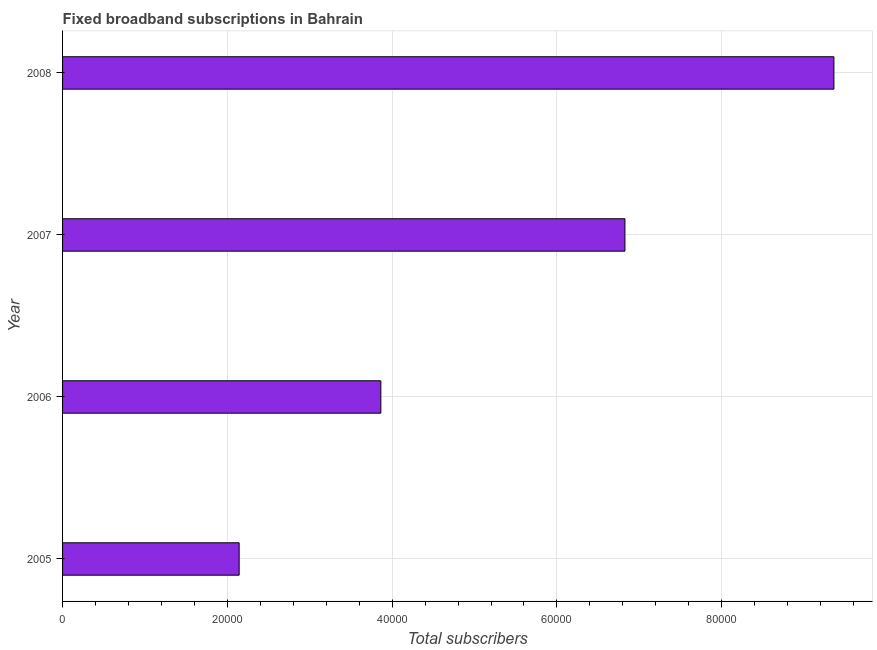Does the graph contain any zero values?
Offer a terse response. No. Does the graph contain grids?
Offer a very short reply. Yes. What is the title of the graph?
Your response must be concise. Fixed broadband subscriptions in Bahrain. What is the label or title of the X-axis?
Your response must be concise. Total subscribers. What is the total number of fixed broadband subscriptions in 2005?
Your response must be concise. 2.14e+04. Across all years, what is the maximum total number of fixed broadband subscriptions?
Make the answer very short. 9.36e+04. Across all years, what is the minimum total number of fixed broadband subscriptions?
Your answer should be very brief. 2.14e+04. In which year was the total number of fixed broadband subscriptions minimum?
Ensure brevity in your answer.  2005. What is the sum of the total number of fixed broadband subscriptions?
Offer a very short reply. 2.22e+05. What is the difference between the total number of fixed broadband subscriptions in 2006 and 2007?
Make the answer very short. -2.96e+04. What is the average total number of fixed broadband subscriptions per year?
Your answer should be compact. 5.55e+04. What is the median total number of fixed broadband subscriptions?
Offer a very short reply. 5.34e+04. Do a majority of the years between 2006 and 2007 (inclusive) have total number of fixed broadband subscriptions greater than 4000 ?
Your answer should be compact. Yes. What is the ratio of the total number of fixed broadband subscriptions in 2006 to that in 2008?
Your answer should be compact. 0.41. What is the difference between the highest and the second highest total number of fixed broadband subscriptions?
Ensure brevity in your answer.  2.54e+04. Is the sum of the total number of fixed broadband subscriptions in 2007 and 2008 greater than the maximum total number of fixed broadband subscriptions across all years?
Ensure brevity in your answer.  Yes. What is the difference between the highest and the lowest total number of fixed broadband subscriptions?
Offer a very short reply. 7.22e+04. How many bars are there?
Offer a terse response. 4. How many years are there in the graph?
Your answer should be compact. 4. What is the difference between two consecutive major ticks on the X-axis?
Your response must be concise. 2.00e+04. What is the Total subscribers in 2005?
Keep it short and to the point. 2.14e+04. What is the Total subscribers in 2006?
Give a very brief answer. 3.86e+04. What is the Total subscribers in 2007?
Provide a succinct answer. 6.83e+04. What is the Total subscribers of 2008?
Keep it short and to the point. 9.36e+04. What is the difference between the Total subscribers in 2005 and 2006?
Your answer should be very brief. -1.72e+04. What is the difference between the Total subscribers in 2005 and 2007?
Give a very brief answer. -4.68e+04. What is the difference between the Total subscribers in 2005 and 2008?
Give a very brief answer. -7.22e+04. What is the difference between the Total subscribers in 2006 and 2007?
Ensure brevity in your answer.  -2.96e+04. What is the difference between the Total subscribers in 2006 and 2008?
Ensure brevity in your answer.  -5.50e+04. What is the difference between the Total subscribers in 2007 and 2008?
Offer a terse response. -2.54e+04. What is the ratio of the Total subscribers in 2005 to that in 2006?
Ensure brevity in your answer.  0.56. What is the ratio of the Total subscribers in 2005 to that in 2007?
Provide a short and direct response. 0.31. What is the ratio of the Total subscribers in 2005 to that in 2008?
Offer a terse response. 0.23. What is the ratio of the Total subscribers in 2006 to that in 2007?
Offer a very short reply. 0.57. What is the ratio of the Total subscribers in 2006 to that in 2008?
Your answer should be compact. 0.41. What is the ratio of the Total subscribers in 2007 to that in 2008?
Ensure brevity in your answer.  0.73. 